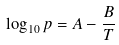Convert formula to latex. <formula><loc_0><loc_0><loc_500><loc_500>\log _ { 1 0 } p = A - \frac { B } { T }</formula> 